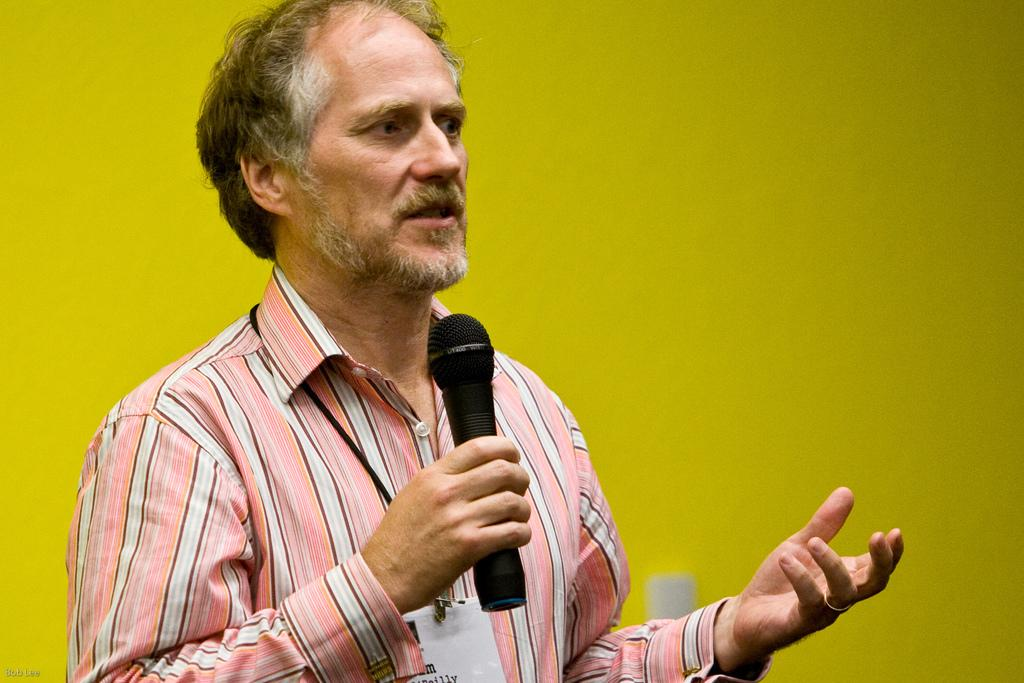What is the color of the wall in the image? There is a yellow color wall in the image. Who is present in the image? There is a man in the image. What is the man holding in the image? The man is holding a mic. How many cents are visible on the wall in the image? There are no cents visible on the wall in the image; it is a solid yellow color. What type of change is the man holding in the image? The man is not holding any change in the image; he is holding a mic. 